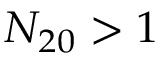<formula> <loc_0><loc_0><loc_500><loc_500>N _ { 2 0 } > 1</formula> 